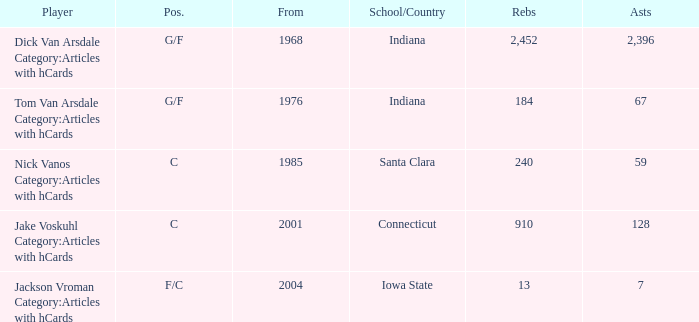What is the average rebounds for players from 1976 and over 67 assists? None. 